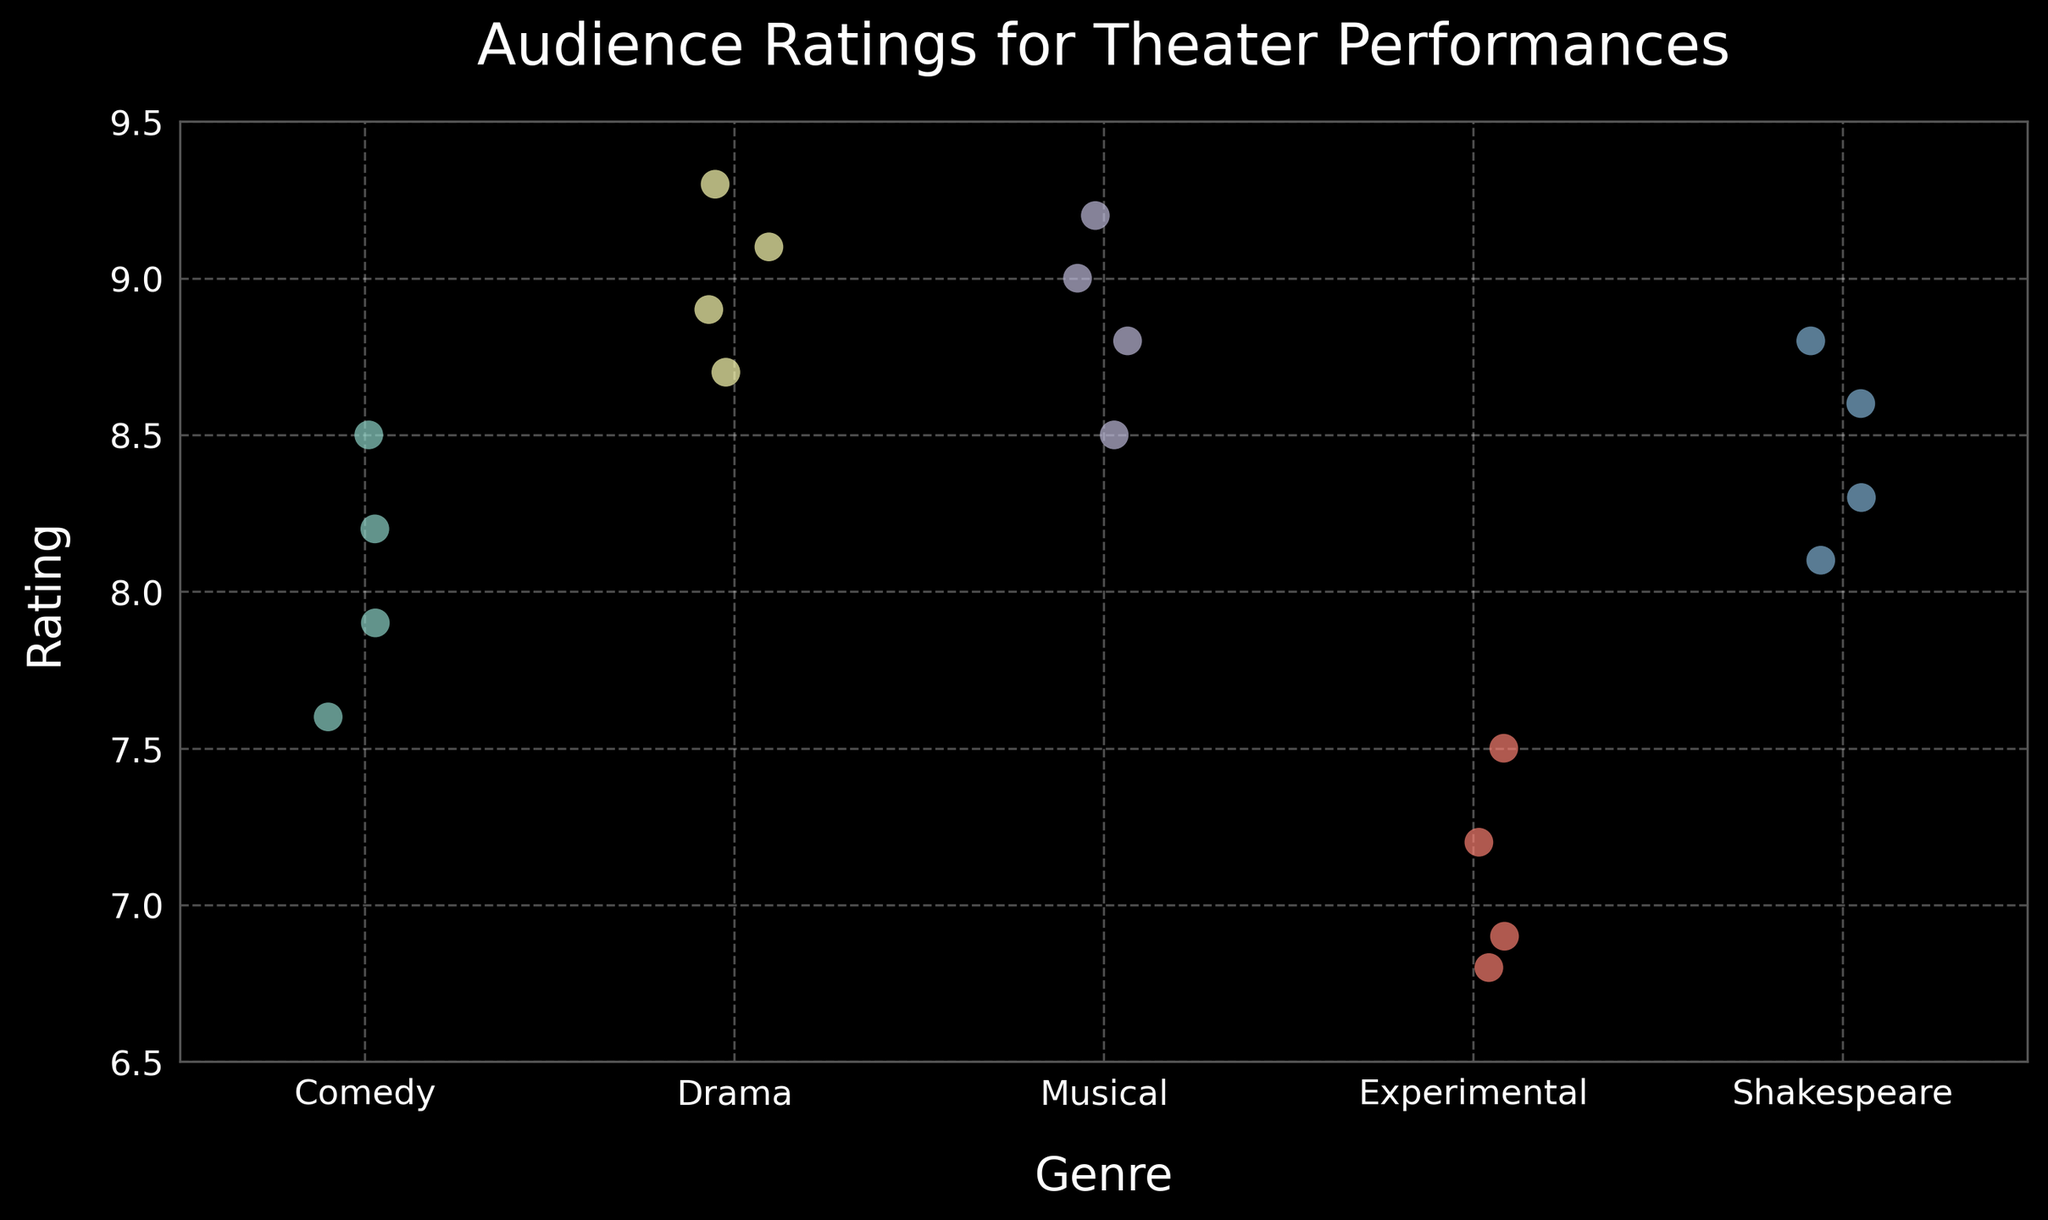How many genres are represented in the plot? By looking at the x-axis, which represents different genres, we can count the number of unique genres displayed in the plot.
Answer: 5 What is the title of the plot? The title is displayed at the top of the plot.
Answer: "Audience Ratings for Theater Performances" What is the range of ratings displayed on the y-axis? The y-axis displays the range of ratings from the minimum to the maximum value.
Answer: 6.5 to 9.5 Which genre has the highest average rating? To find the average rating for each genre, identify the ratings for each genre and calculate the mean. Drama: (9.1 + 8.7 + 8.9 + 9.3) / 4 = 9.0. The average rating is compared across genres to determine the highest.
Answer: Drama How do the ratings for Experimental performances compare to Musical performances? By selecting the 'Experimental' and 'Musical' genres and comparing their displayed ratings, we observe that the Experimental genre has lower ratings, falling between 6.8 and 7.5, while Musical performances fall between 8.5 and 9.2.
Answer: Experimental ratings are lower What's the minimum rating for the Comedy genre? Identify the ratings for Comedy and select the smallest value: Comedy: 8.2, 7.9, 8.5, 7.6. The minimum rating is 7.6.
Answer: 7.6 What is the unique color scheme used for this plot? Observe the colors used for the data points representing different genres. The plot uses a predefined color palette commonly known as 'Set3'.
Answer: Set3 palette How many data points represent Musical performances? Count the number of data points in the Musical genre by inspecting the Musical ratings.
Answer: 4 Which genre has the most variability in ratings? Variability can be assessed by observing the spread of data points within each genre. Experimental performances have the widest range from 6.8 to 7.5, compared to the other genres with ratings that are closer to each other.
Answer: Experimental How does the grid style affect the visibility of the data? The plot uses a dashed grid line style with lower alpha transparency, making the grid apparent but not overpowering the overall visual data points. This ensures that the grid aids in reference without distracting from the data.
Answer: Enhances clarity without distraction 